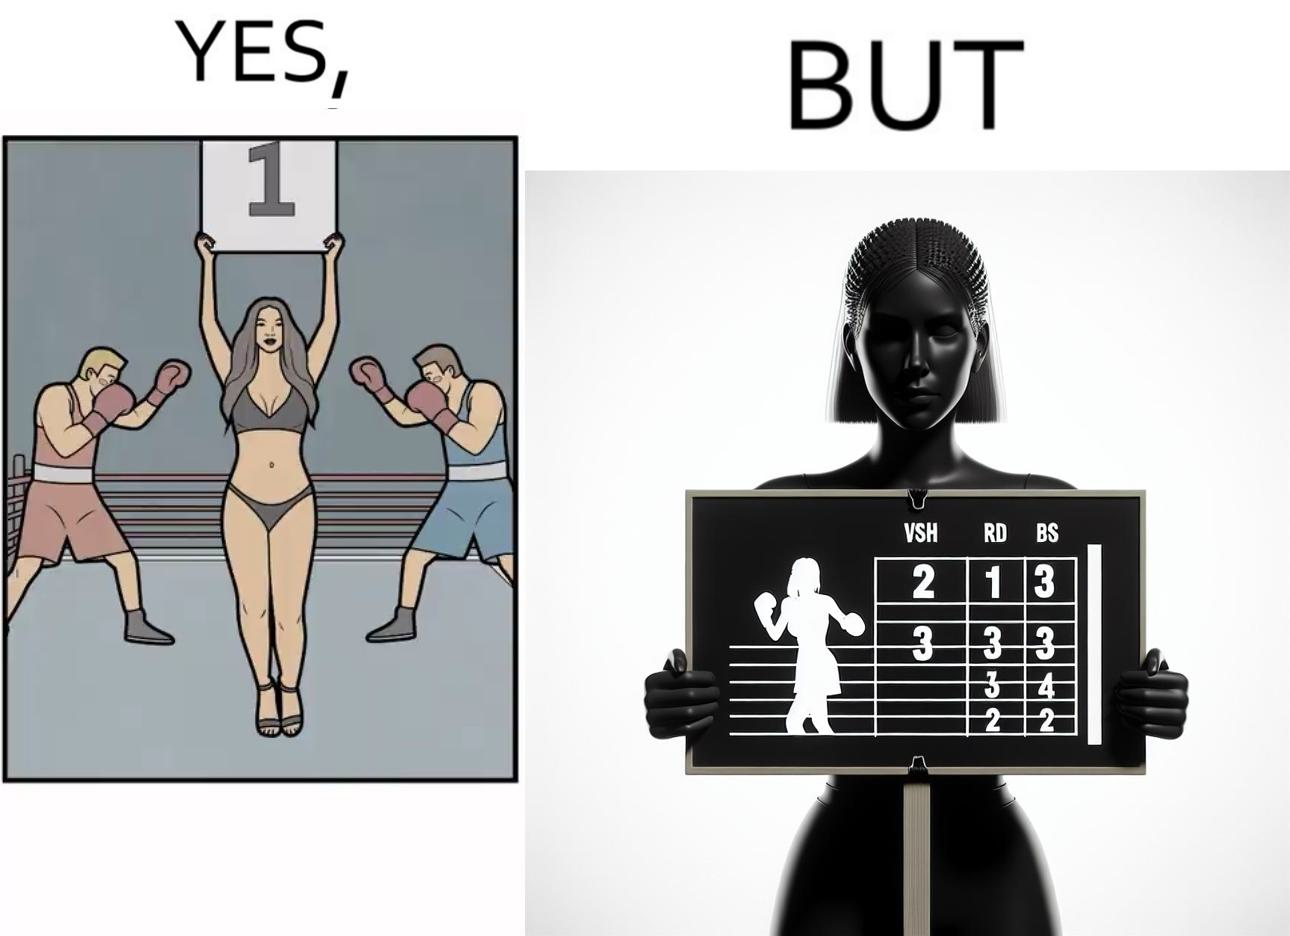Would you classify this image as satirical? Yes, this image is satirical. 